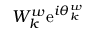Convert formula to latex. <formula><loc_0><loc_0><loc_500><loc_500>W _ { k } ^ { w } e ^ { i \theta _ { k } ^ { w } }</formula> 